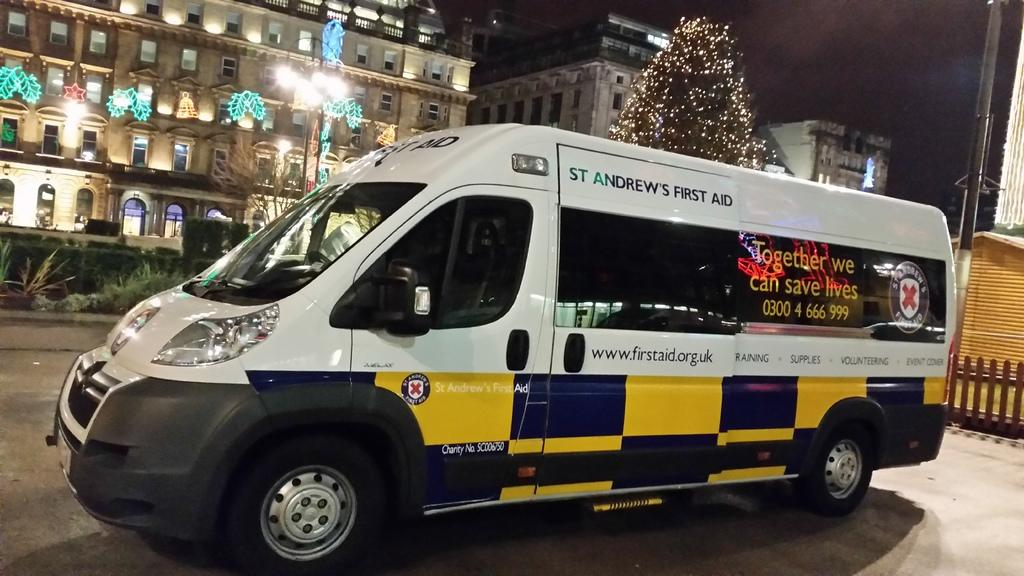<image>
Describe the image concisely. a st. andrews first aid vehicle with yellow and blue on the bottom 